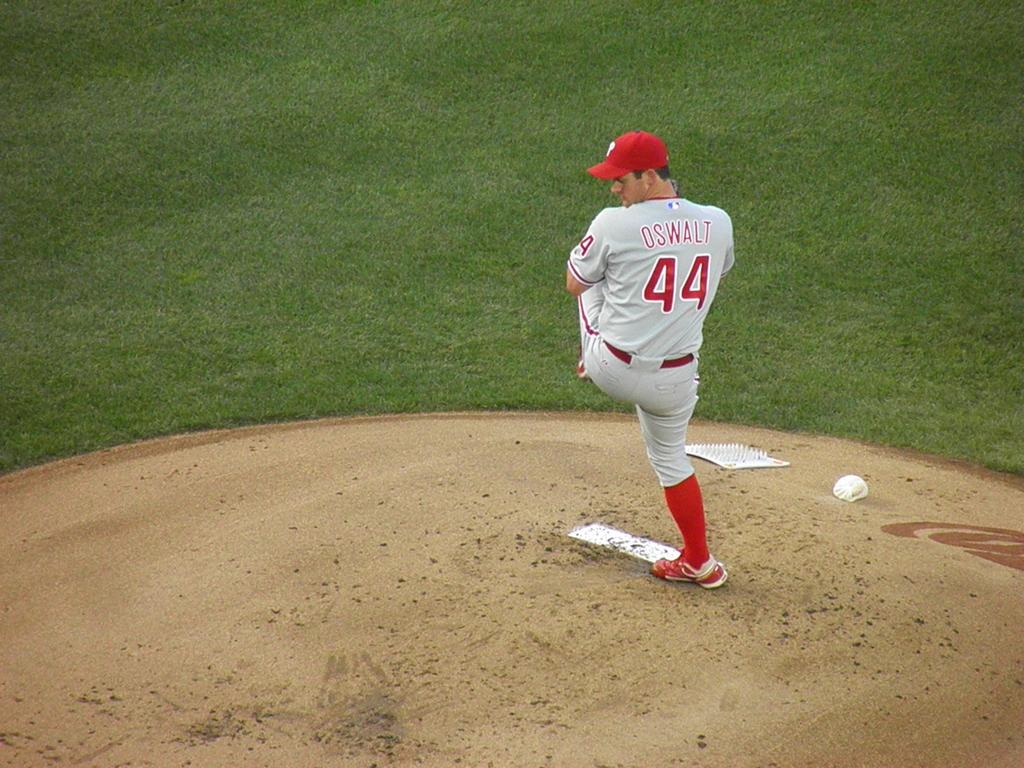<image>
Give a short and clear explanation of the subsequent image. A baseball player has a jersey on with the number 44 on it. 